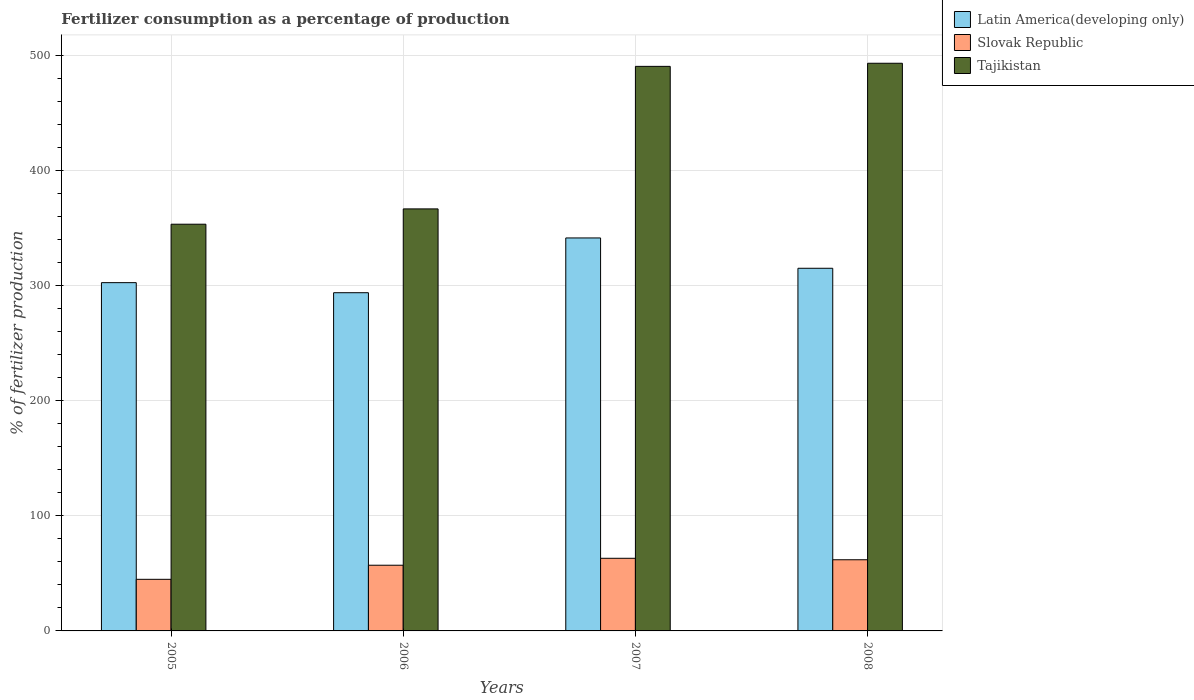Are the number of bars per tick equal to the number of legend labels?
Keep it short and to the point. Yes. Are the number of bars on each tick of the X-axis equal?
Provide a succinct answer. Yes. How many bars are there on the 3rd tick from the left?
Your response must be concise. 3. What is the label of the 3rd group of bars from the left?
Give a very brief answer. 2007. What is the percentage of fertilizers consumed in Tajikistan in 2007?
Keep it short and to the point. 490.68. Across all years, what is the maximum percentage of fertilizers consumed in Tajikistan?
Your answer should be compact. 493.38. Across all years, what is the minimum percentage of fertilizers consumed in Tajikistan?
Keep it short and to the point. 353.49. In which year was the percentage of fertilizers consumed in Tajikistan minimum?
Provide a short and direct response. 2005. What is the total percentage of fertilizers consumed in Slovak Republic in the graph?
Your answer should be compact. 226.92. What is the difference between the percentage of fertilizers consumed in Latin America(developing only) in 2006 and that in 2008?
Make the answer very short. -21.25. What is the difference between the percentage of fertilizers consumed in Tajikistan in 2007 and the percentage of fertilizers consumed in Latin America(developing only) in 2008?
Your answer should be compact. 175.48. What is the average percentage of fertilizers consumed in Tajikistan per year?
Your answer should be compact. 426.09. In the year 2007, what is the difference between the percentage of fertilizers consumed in Latin America(developing only) and percentage of fertilizers consumed in Slovak Republic?
Your response must be concise. 278.43. What is the ratio of the percentage of fertilizers consumed in Slovak Republic in 2005 to that in 2007?
Make the answer very short. 0.71. What is the difference between the highest and the second highest percentage of fertilizers consumed in Slovak Republic?
Give a very brief answer. 1.28. What is the difference between the highest and the lowest percentage of fertilizers consumed in Tajikistan?
Make the answer very short. 139.89. What does the 3rd bar from the left in 2008 represents?
Provide a succinct answer. Tajikistan. What does the 1st bar from the right in 2006 represents?
Your answer should be very brief. Tajikistan. Is it the case that in every year, the sum of the percentage of fertilizers consumed in Slovak Republic and percentage of fertilizers consumed in Latin America(developing only) is greater than the percentage of fertilizers consumed in Tajikistan?
Provide a short and direct response. No. Are all the bars in the graph horizontal?
Give a very brief answer. No. What is the difference between two consecutive major ticks on the Y-axis?
Make the answer very short. 100. Are the values on the major ticks of Y-axis written in scientific E-notation?
Your response must be concise. No. Does the graph contain grids?
Provide a short and direct response. Yes. Where does the legend appear in the graph?
Your response must be concise. Top right. What is the title of the graph?
Your answer should be compact. Fertilizer consumption as a percentage of production. Does "OECD members" appear as one of the legend labels in the graph?
Ensure brevity in your answer.  No. What is the label or title of the Y-axis?
Keep it short and to the point. % of fertilizer production. What is the % of fertilizer production of Latin America(developing only) in 2005?
Your response must be concise. 302.7. What is the % of fertilizer production of Slovak Republic in 2005?
Your answer should be very brief. 44.85. What is the % of fertilizer production of Tajikistan in 2005?
Make the answer very short. 353.49. What is the % of fertilizer production in Latin America(developing only) in 2006?
Offer a terse response. 293.95. What is the % of fertilizer production of Slovak Republic in 2006?
Provide a succinct answer. 57.1. What is the % of fertilizer production of Tajikistan in 2006?
Ensure brevity in your answer.  366.81. What is the % of fertilizer production of Latin America(developing only) in 2007?
Your response must be concise. 341.55. What is the % of fertilizer production of Slovak Republic in 2007?
Offer a terse response. 63.13. What is the % of fertilizer production of Tajikistan in 2007?
Give a very brief answer. 490.68. What is the % of fertilizer production of Latin America(developing only) in 2008?
Your response must be concise. 315.2. What is the % of fertilizer production of Slovak Republic in 2008?
Your answer should be compact. 61.84. What is the % of fertilizer production of Tajikistan in 2008?
Ensure brevity in your answer.  493.38. Across all years, what is the maximum % of fertilizer production of Latin America(developing only)?
Offer a terse response. 341.55. Across all years, what is the maximum % of fertilizer production of Slovak Republic?
Ensure brevity in your answer.  63.13. Across all years, what is the maximum % of fertilizer production of Tajikistan?
Provide a short and direct response. 493.38. Across all years, what is the minimum % of fertilizer production in Latin America(developing only)?
Your response must be concise. 293.95. Across all years, what is the minimum % of fertilizer production of Slovak Republic?
Provide a short and direct response. 44.85. Across all years, what is the minimum % of fertilizer production of Tajikistan?
Ensure brevity in your answer.  353.49. What is the total % of fertilizer production in Latin America(developing only) in the graph?
Offer a very short reply. 1253.41. What is the total % of fertilizer production in Slovak Republic in the graph?
Make the answer very short. 226.92. What is the total % of fertilizer production in Tajikistan in the graph?
Your response must be concise. 1704.37. What is the difference between the % of fertilizer production in Latin America(developing only) in 2005 and that in 2006?
Your answer should be very brief. 8.75. What is the difference between the % of fertilizer production in Slovak Republic in 2005 and that in 2006?
Offer a terse response. -12.25. What is the difference between the % of fertilizer production of Tajikistan in 2005 and that in 2006?
Make the answer very short. -13.31. What is the difference between the % of fertilizer production in Latin America(developing only) in 2005 and that in 2007?
Your answer should be compact. -38.85. What is the difference between the % of fertilizer production in Slovak Republic in 2005 and that in 2007?
Offer a very short reply. -18.28. What is the difference between the % of fertilizer production in Tajikistan in 2005 and that in 2007?
Your answer should be compact. -137.19. What is the difference between the % of fertilizer production in Latin America(developing only) in 2005 and that in 2008?
Your response must be concise. -12.5. What is the difference between the % of fertilizer production in Slovak Republic in 2005 and that in 2008?
Your response must be concise. -17. What is the difference between the % of fertilizer production of Tajikistan in 2005 and that in 2008?
Your answer should be very brief. -139.89. What is the difference between the % of fertilizer production of Latin America(developing only) in 2006 and that in 2007?
Your answer should be compact. -47.6. What is the difference between the % of fertilizer production in Slovak Republic in 2006 and that in 2007?
Provide a short and direct response. -6.03. What is the difference between the % of fertilizer production of Tajikistan in 2006 and that in 2007?
Offer a terse response. -123.88. What is the difference between the % of fertilizer production of Latin America(developing only) in 2006 and that in 2008?
Keep it short and to the point. -21.25. What is the difference between the % of fertilizer production of Slovak Republic in 2006 and that in 2008?
Give a very brief answer. -4.75. What is the difference between the % of fertilizer production of Tajikistan in 2006 and that in 2008?
Your answer should be compact. -126.58. What is the difference between the % of fertilizer production in Latin America(developing only) in 2007 and that in 2008?
Your answer should be compact. 26.35. What is the difference between the % of fertilizer production in Slovak Republic in 2007 and that in 2008?
Provide a succinct answer. 1.28. What is the difference between the % of fertilizer production of Tajikistan in 2007 and that in 2008?
Provide a short and direct response. -2.7. What is the difference between the % of fertilizer production of Latin America(developing only) in 2005 and the % of fertilizer production of Slovak Republic in 2006?
Your answer should be compact. 245.6. What is the difference between the % of fertilizer production in Latin America(developing only) in 2005 and the % of fertilizer production in Tajikistan in 2006?
Ensure brevity in your answer.  -64.11. What is the difference between the % of fertilizer production in Slovak Republic in 2005 and the % of fertilizer production in Tajikistan in 2006?
Provide a succinct answer. -321.96. What is the difference between the % of fertilizer production in Latin America(developing only) in 2005 and the % of fertilizer production in Slovak Republic in 2007?
Offer a very short reply. 239.57. What is the difference between the % of fertilizer production of Latin America(developing only) in 2005 and the % of fertilizer production of Tajikistan in 2007?
Offer a very short reply. -187.98. What is the difference between the % of fertilizer production in Slovak Republic in 2005 and the % of fertilizer production in Tajikistan in 2007?
Give a very brief answer. -445.84. What is the difference between the % of fertilizer production in Latin America(developing only) in 2005 and the % of fertilizer production in Slovak Republic in 2008?
Provide a succinct answer. 240.86. What is the difference between the % of fertilizer production in Latin America(developing only) in 2005 and the % of fertilizer production in Tajikistan in 2008?
Your answer should be very brief. -190.68. What is the difference between the % of fertilizer production in Slovak Republic in 2005 and the % of fertilizer production in Tajikistan in 2008?
Your answer should be compact. -448.54. What is the difference between the % of fertilizer production in Latin America(developing only) in 2006 and the % of fertilizer production in Slovak Republic in 2007?
Your answer should be compact. 230.82. What is the difference between the % of fertilizer production of Latin America(developing only) in 2006 and the % of fertilizer production of Tajikistan in 2007?
Your answer should be very brief. -196.73. What is the difference between the % of fertilizer production of Slovak Republic in 2006 and the % of fertilizer production of Tajikistan in 2007?
Offer a very short reply. -433.58. What is the difference between the % of fertilizer production of Latin America(developing only) in 2006 and the % of fertilizer production of Slovak Republic in 2008?
Give a very brief answer. 232.11. What is the difference between the % of fertilizer production in Latin America(developing only) in 2006 and the % of fertilizer production in Tajikistan in 2008?
Provide a short and direct response. -199.43. What is the difference between the % of fertilizer production in Slovak Republic in 2006 and the % of fertilizer production in Tajikistan in 2008?
Offer a very short reply. -436.28. What is the difference between the % of fertilizer production in Latin America(developing only) in 2007 and the % of fertilizer production in Slovak Republic in 2008?
Keep it short and to the point. 279.71. What is the difference between the % of fertilizer production of Latin America(developing only) in 2007 and the % of fertilizer production of Tajikistan in 2008?
Provide a succinct answer. -151.83. What is the difference between the % of fertilizer production in Slovak Republic in 2007 and the % of fertilizer production in Tajikistan in 2008?
Offer a very short reply. -430.26. What is the average % of fertilizer production of Latin America(developing only) per year?
Offer a very short reply. 313.35. What is the average % of fertilizer production of Slovak Republic per year?
Provide a short and direct response. 56.73. What is the average % of fertilizer production in Tajikistan per year?
Make the answer very short. 426.09. In the year 2005, what is the difference between the % of fertilizer production in Latin America(developing only) and % of fertilizer production in Slovak Republic?
Give a very brief answer. 257.85. In the year 2005, what is the difference between the % of fertilizer production of Latin America(developing only) and % of fertilizer production of Tajikistan?
Ensure brevity in your answer.  -50.79. In the year 2005, what is the difference between the % of fertilizer production in Slovak Republic and % of fertilizer production in Tajikistan?
Provide a short and direct response. -308.65. In the year 2006, what is the difference between the % of fertilizer production of Latin America(developing only) and % of fertilizer production of Slovak Republic?
Your response must be concise. 236.85. In the year 2006, what is the difference between the % of fertilizer production in Latin America(developing only) and % of fertilizer production in Tajikistan?
Your answer should be compact. -72.85. In the year 2006, what is the difference between the % of fertilizer production in Slovak Republic and % of fertilizer production in Tajikistan?
Ensure brevity in your answer.  -309.71. In the year 2007, what is the difference between the % of fertilizer production in Latin America(developing only) and % of fertilizer production in Slovak Republic?
Make the answer very short. 278.43. In the year 2007, what is the difference between the % of fertilizer production of Latin America(developing only) and % of fertilizer production of Tajikistan?
Ensure brevity in your answer.  -149.13. In the year 2007, what is the difference between the % of fertilizer production in Slovak Republic and % of fertilizer production in Tajikistan?
Offer a terse response. -427.56. In the year 2008, what is the difference between the % of fertilizer production of Latin America(developing only) and % of fertilizer production of Slovak Republic?
Keep it short and to the point. 253.36. In the year 2008, what is the difference between the % of fertilizer production of Latin America(developing only) and % of fertilizer production of Tajikistan?
Your response must be concise. -178.18. In the year 2008, what is the difference between the % of fertilizer production of Slovak Republic and % of fertilizer production of Tajikistan?
Your response must be concise. -431.54. What is the ratio of the % of fertilizer production of Latin America(developing only) in 2005 to that in 2006?
Provide a short and direct response. 1.03. What is the ratio of the % of fertilizer production in Slovak Republic in 2005 to that in 2006?
Provide a succinct answer. 0.79. What is the ratio of the % of fertilizer production in Tajikistan in 2005 to that in 2006?
Your response must be concise. 0.96. What is the ratio of the % of fertilizer production of Latin America(developing only) in 2005 to that in 2007?
Offer a terse response. 0.89. What is the ratio of the % of fertilizer production of Slovak Republic in 2005 to that in 2007?
Your answer should be compact. 0.71. What is the ratio of the % of fertilizer production of Tajikistan in 2005 to that in 2007?
Make the answer very short. 0.72. What is the ratio of the % of fertilizer production in Latin America(developing only) in 2005 to that in 2008?
Provide a short and direct response. 0.96. What is the ratio of the % of fertilizer production of Slovak Republic in 2005 to that in 2008?
Keep it short and to the point. 0.73. What is the ratio of the % of fertilizer production of Tajikistan in 2005 to that in 2008?
Offer a very short reply. 0.72. What is the ratio of the % of fertilizer production in Latin America(developing only) in 2006 to that in 2007?
Provide a succinct answer. 0.86. What is the ratio of the % of fertilizer production in Slovak Republic in 2006 to that in 2007?
Give a very brief answer. 0.9. What is the ratio of the % of fertilizer production of Tajikistan in 2006 to that in 2007?
Offer a terse response. 0.75. What is the ratio of the % of fertilizer production in Latin America(developing only) in 2006 to that in 2008?
Provide a succinct answer. 0.93. What is the ratio of the % of fertilizer production of Slovak Republic in 2006 to that in 2008?
Your response must be concise. 0.92. What is the ratio of the % of fertilizer production in Tajikistan in 2006 to that in 2008?
Give a very brief answer. 0.74. What is the ratio of the % of fertilizer production in Latin America(developing only) in 2007 to that in 2008?
Give a very brief answer. 1.08. What is the ratio of the % of fertilizer production of Slovak Republic in 2007 to that in 2008?
Your response must be concise. 1.02. What is the ratio of the % of fertilizer production in Tajikistan in 2007 to that in 2008?
Make the answer very short. 0.99. What is the difference between the highest and the second highest % of fertilizer production in Latin America(developing only)?
Provide a short and direct response. 26.35. What is the difference between the highest and the second highest % of fertilizer production of Slovak Republic?
Offer a terse response. 1.28. What is the difference between the highest and the second highest % of fertilizer production in Tajikistan?
Your answer should be very brief. 2.7. What is the difference between the highest and the lowest % of fertilizer production in Latin America(developing only)?
Offer a very short reply. 47.6. What is the difference between the highest and the lowest % of fertilizer production in Slovak Republic?
Your response must be concise. 18.28. What is the difference between the highest and the lowest % of fertilizer production of Tajikistan?
Your answer should be compact. 139.89. 